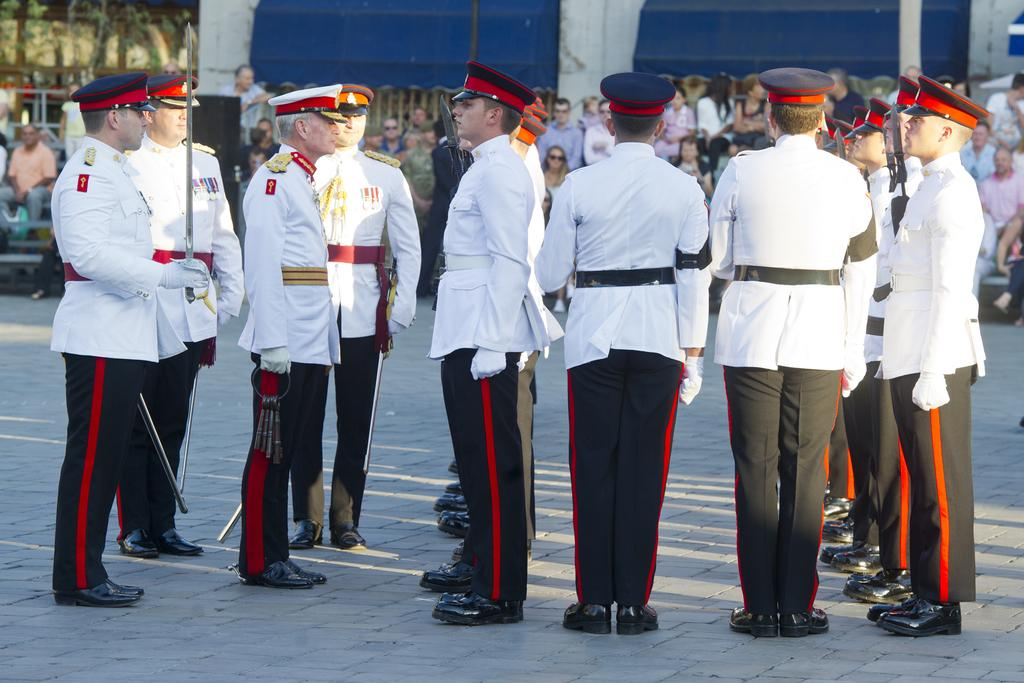How many people are visible in the image? There are people in the image, but the exact number is not specified in the facts. What are the people wearing? The people are wearing common dress. What are the people holding? The people are standing and holding objects. Can you describe the people behind the standing people? Some of the people behind are standing, while others are sitting. What type of table is being used to sort the objects in the image? There is no table present in the image, and the objects are not being sorted. 